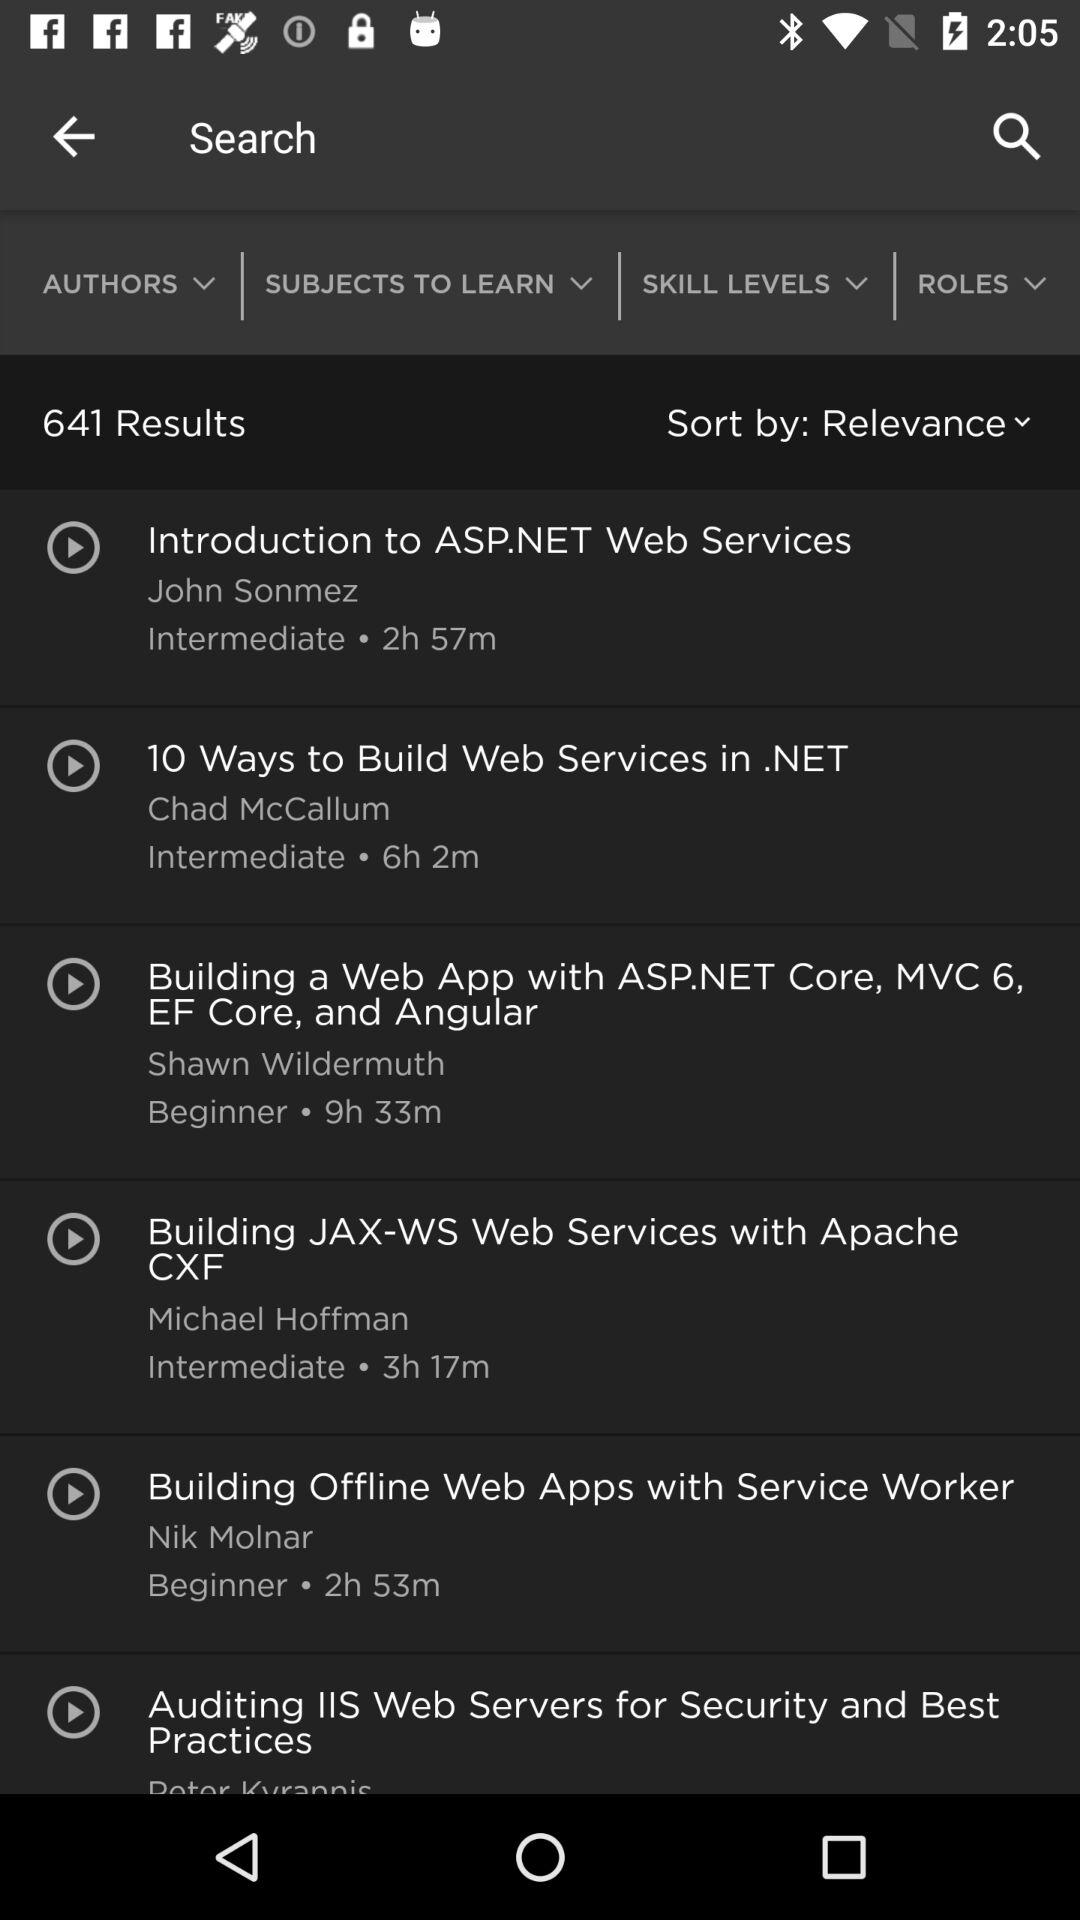How many results in total are there? There are 641 results. 